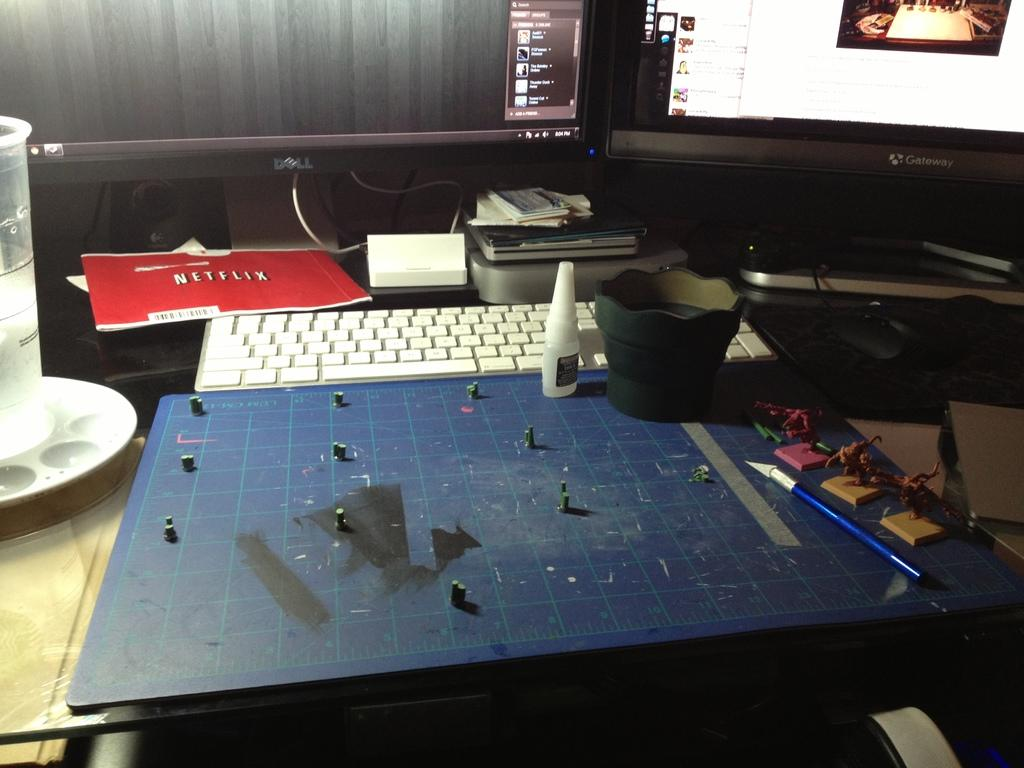What type of table is in the image? There is a glass table in the image. What electronic devices can be seen on the table? There are two computers, a keyboard, a cup, glue, a motherboard, a CD disk box, and other electronic gadgets on the table. Can you describe the arrangement of the items on the table? The items are arranged on the table, with the two computers, keyboard, cup, glue, motherboard, and CD disk box being visible. What might be used for storing or organizing CDs in the image? The CD disk box on the table can be used for storing or organizing CDs. How does the tail of the cat affect the electronic devices on the table during the earthquake? There is no cat or earthquake present in the image, so it is not possible to answer that question. 